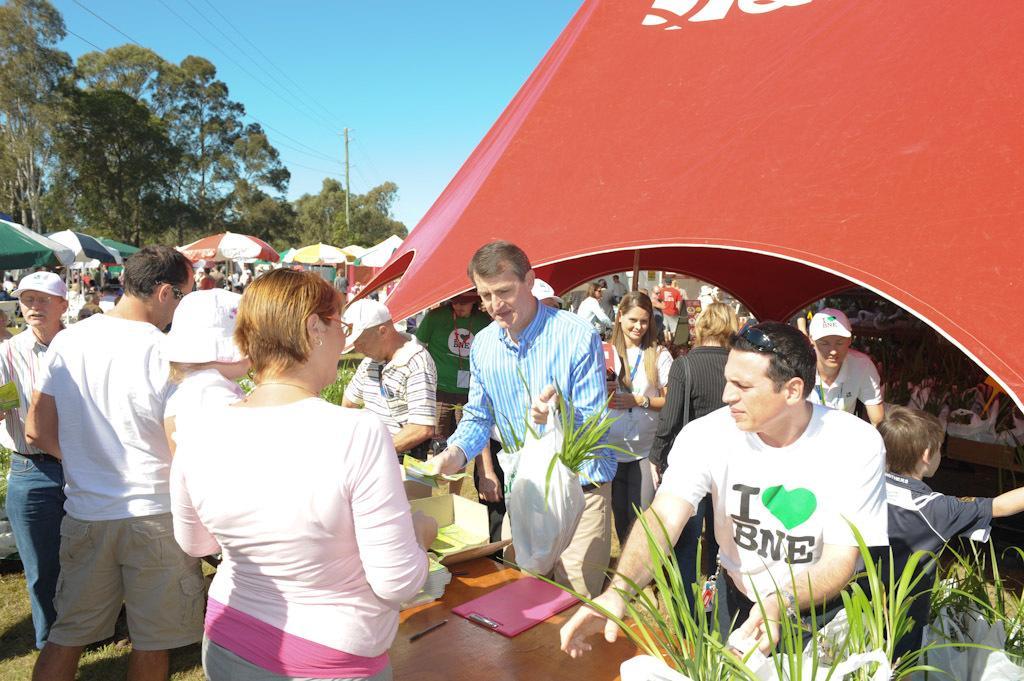Describe this image in one or two sentences. In the bottom right corner of the image there is a table, on the table there are some plants, pencil, pad and there are some boxes. Surrounding the table few people are standing and he is holding a bag and there are some tents. In the top left corner of the image there are some trees and pole. At the top of the image there is sky. 